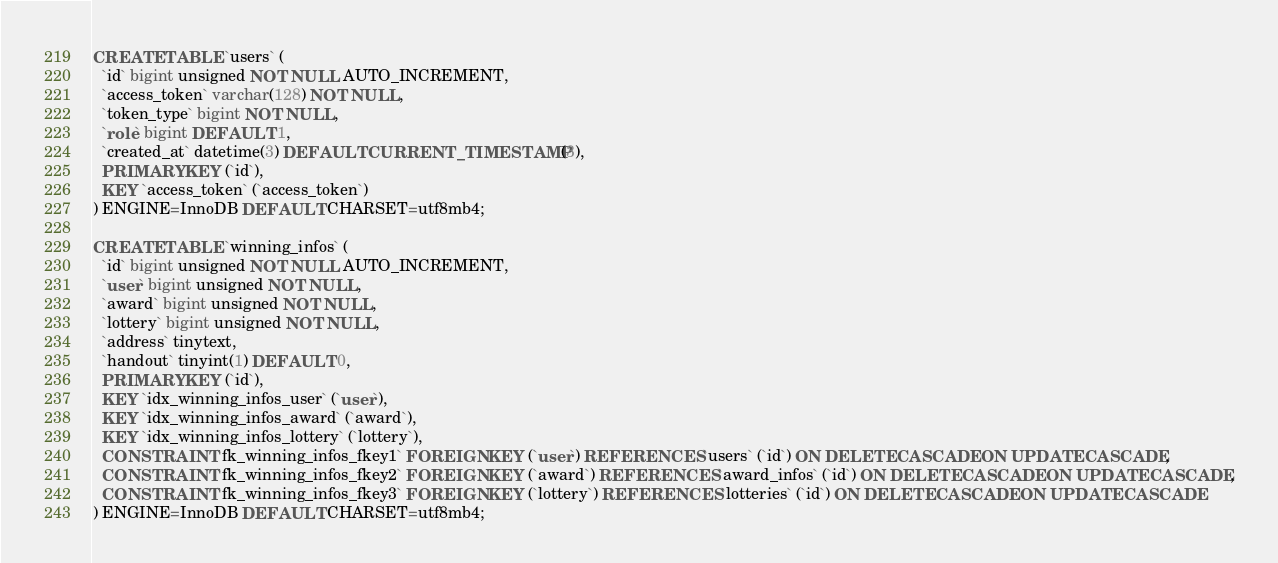<code> <loc_0><loc_0><loc_500><loc_500><_SQL_>
CREATE TABLE `users` (
  `id` bigint unsigned NOT NULL AUTO_INCREMENT,
  `access_token` varchar(128) NOT NULL,
  `token_type` bigint NOT NULL,
  `role` bigint DEFAULT 1,
  `created_at` datetime(3) DEFAULT CURRENT_TIMESTAMP(3),
  PRIMARY KEY (`id`),
  KEY `access_token` (`access_token`)
) ENGINE=InnoDB DEFAULT CHARSET=utf8mb4;

CREATE TABLE `winning_infos` (
  `id` bigint unsigned NOT NULL AUTO_INCREMENT,
  `user` bigint unsigned NOT NULL,
  `award` bigint unsigned NOT NULL,
  `lottery` bigint unsigned NOT NULL,
  `address` tinytext,
  `handout` tinyint(1) DEFAULT 0,
  PRIMARY KEY (`id`),
  KEY `idx_winning_infos_user` (`user`),
  KEY `idx_winning_infos_award` (`award`),
  KEY `idx_winning_infos_lottery` (`lottery`),
  CONSTRAINT `fk_winning_infos_fkey1` FOREIGN KEY (`user`) REFERENCES `users` (`id`) ON DELETE CASCADE ON UPDATE CASCADE,
  CONSTRAINT `fk_winning_infos_fkey2` FOREIGN KEY (`award`) REFERENCES `award_infos` (`id`) ON DELETE CASCADE ON UPDATE CASCADE,
  CONSTRAINT `fk_winning_infos_fkey3` FOREIGN KEY (`lottery`) REFERENCES `lotteries` (`id`) ON DELETE CASCADE ON UPDATE CASCADE
) ENGINE=InnoDB DEFAULT CHARSET=utf8mb4;
</code> 